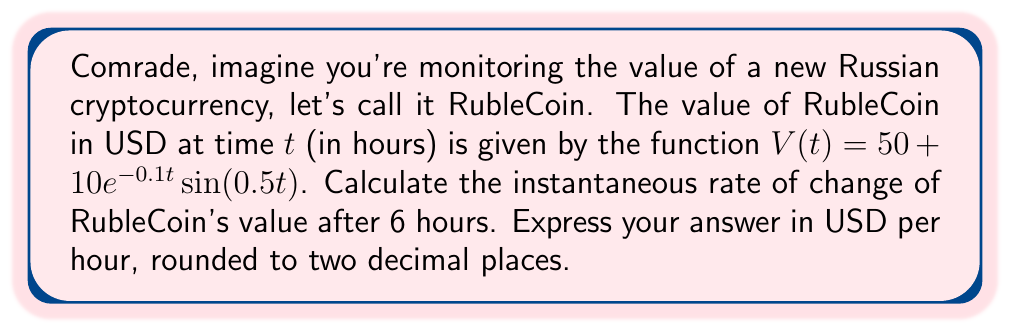Could you help me with this problem? To solve this problem, we need to use derivatives to find the rate of change. Here's the step-by-step process:

1) The function for RubleCoin's value is:
   $V(t) = 50 + 10e^{-0.1t} \sin(0.5t)$

2) To find the rate of change, we need to calculate $\frac{dV}{dt}$. Let's use the product rule and chain rule:

   $$\frac{dV}{dt} = 0 + 10 \cdot \frac{d}{dt}(e^{-0.1t} \sin(0.5t))$$
   $$= 10 \cdot (e^{-0.1t} \cdot \frac{d}{dt}(\sin(0.5t)) + \sin(0.5t) \cdot \frac{d}{dt}(e^{-0.1t}))$$

3) Calculate the derivatives:
   $\frac{d}{dt}(\sin(0.5t)) = 0.5 \cos(0.5t)$
   $\frac{d}{dt}(e^{-0.1t}) = -0.1e^{-0.1t}$

4) Substitute these back into the equation:

   $$\frac{dV}{dt} = 10 \cdot (e^{-0.1t} \cdot 0.5 \cos(0.5t) + \sin(0.5t) \cdot (-0.1e^{-0.1t}))$$
   $$= 10e^{-0.1t} \cdot (0.5 \cos(0.5t) - 0.1 \sin(0.5t))$$

5) Now, we need to evaluate this at $t = 6$:

   $$\frac{dV}{dt}\bigg|_{t=6} = 10e^{-0.1(6)} \cdot (0.5 \cos(0.5(6)) - 0.1 \sin(0.5(6)))$$
   $$= 10e^{-0.6} \cdot (0.5 \cos(3) - 0.1 \sin(3))$$

6) Calculate the numerical value:
   $e^{-0.6} \approx 0.5488$
   $\cos(3) \approx -0.9900$
   $\sin(3) \approx 0.1411$

   $$\frac{dV}{dt}\bigg|_{t=6} \approx 10 \cdot 0.5488 \cdot (0.5 \cdot (-0.9900) - 0.1 \cdot 0.1411)$$
   $$\approx 5.488 \cdot (-0.4950 - 0.01411)$$
   $$\approx 5.488 \cdot (-0.50911)$$
   $$\approx -2.7940$$

7) Rounding to two decimal places: -2.79
Answer: $-2.79$ USD per hour 